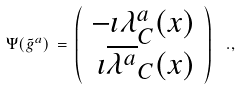<formula> <loc_0><loc_0><loc_500><loc_500>\Psi ( \tilde { g } ^ { a } ) \, = \, \left ( \begin{array} { r } - \imath \lambda ^ { a } _ { C } ( x ) \\ \imath \overline { \lambda ^ { a } } _ { C } ( x ) \end{array} \right ) \, \ . ,</formula> 